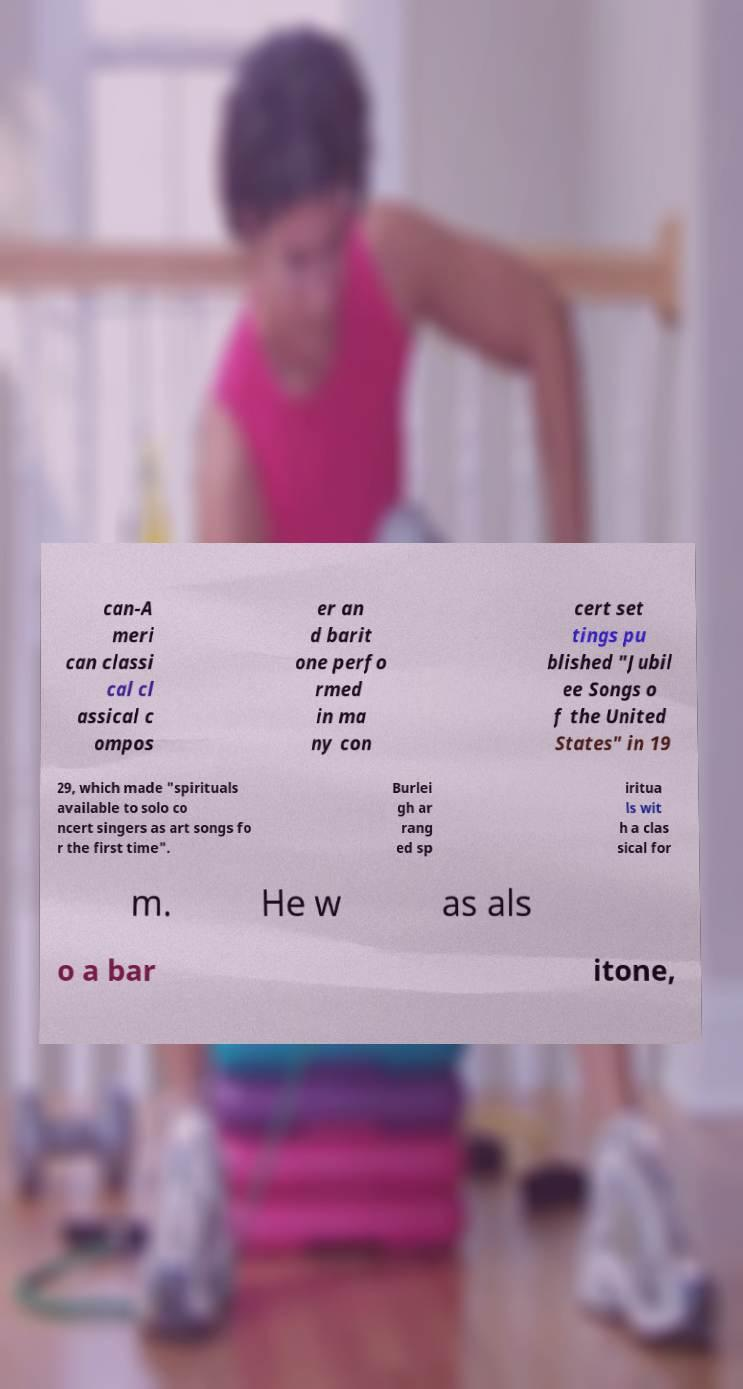There's text embedded in this image that I need extracted. Can you transcribe it verbatim? can-A meri can classi cal cl assical c ompos er an d barit one perfo rmed in ma ny con cert set tings pu blished "Jubil ee Songs o f the United States" in 19 29, which made "spirituals available to solo co ncert singers as art songs fo r the first time". Burlei gh ar rang ed sp iritua ls wit h a clas sical for m. He w as als o a bar itone, 